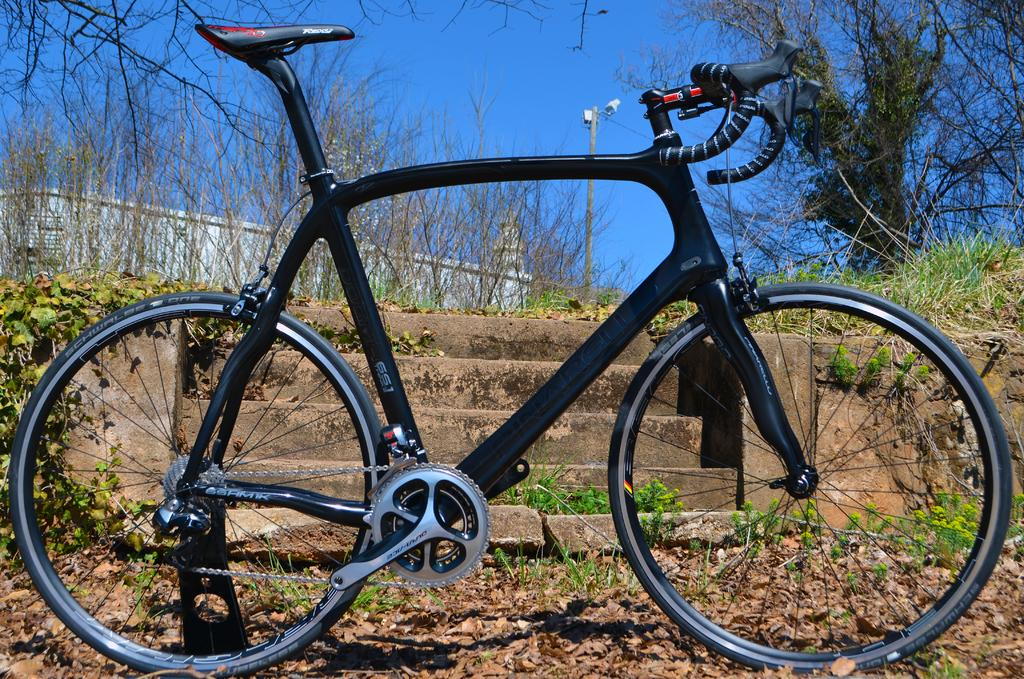What is the main subject in the center of the image? There is a bicycle in the center of the image. What is the color of the bicycle? The bicycle is black. What can be seen in the background of the image? Sky, trees, plants, grass, dry leaves, a pole, a staircase, and a fence are visible in the background of the image. Can you see any waves in the image? No, there are no waves present in the image. 